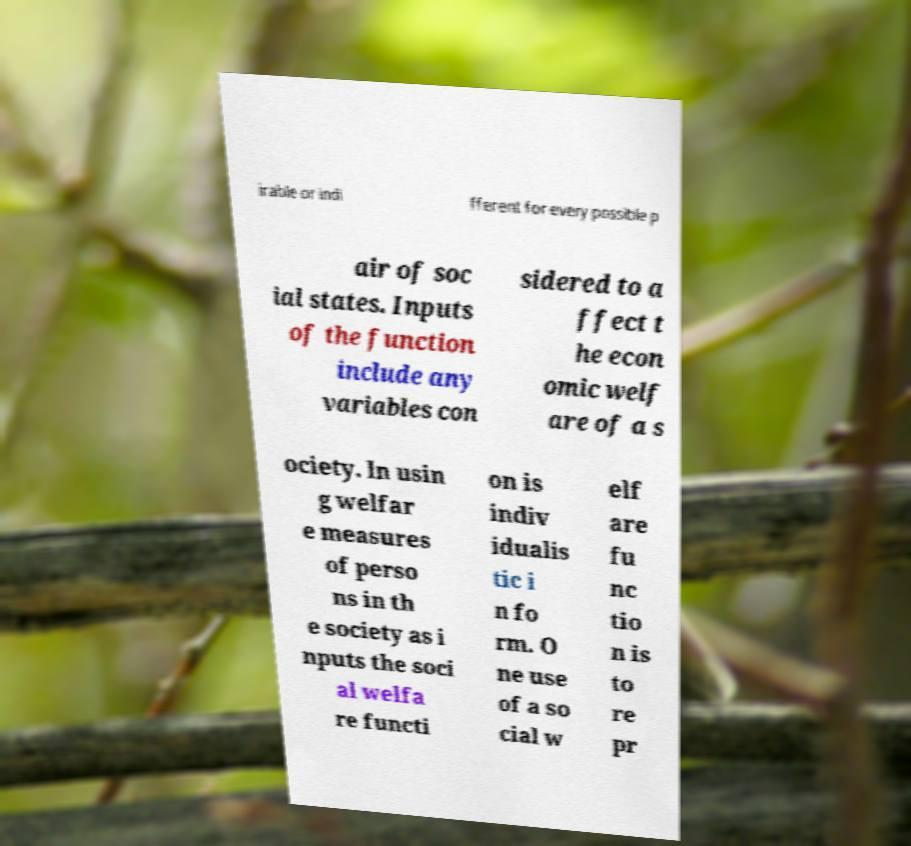Can you accurately transcribe the text from the provided image for me? irable or indi fferent for every possible p air of soc ial states. Inputs of the function include any variables con sidered to a ffect t he econ omic welf are of a s ociety. In usin g welfar e measures of perso ns in th e society as i nputs the soci al welfa re functi on is indiv idualis tic i n fo rm. O ne use of a so cial w elf are fu nc tio n is to re pr 